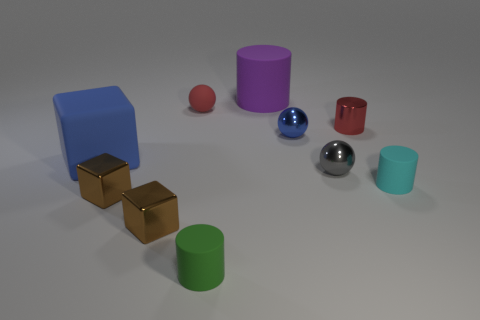Subtract all matte blocks. How many blocks are left? 2 Subtract all blue cubes. How many cubes are left? 2 Subtract all cylinders. How many objects are left? 6 Subtract 1 spheres. How many spheres are left? 2 Subtract all tiny green cylinders. Subtract all big yellow metallic cubes. How many objects are left? 9 Add 2 large matte cubes. How many large matte cubes are left? 3 Add 7 small green rubber spheres. How many small green rubber spheres exist? 7 Subtract 1 red spheres. How many objects are left? 9 Subtract all green cylinders. Subtract all yellow blocks. How many cylinders are left? 3 Subtract all blue blocks. How many green balls are left? 0 